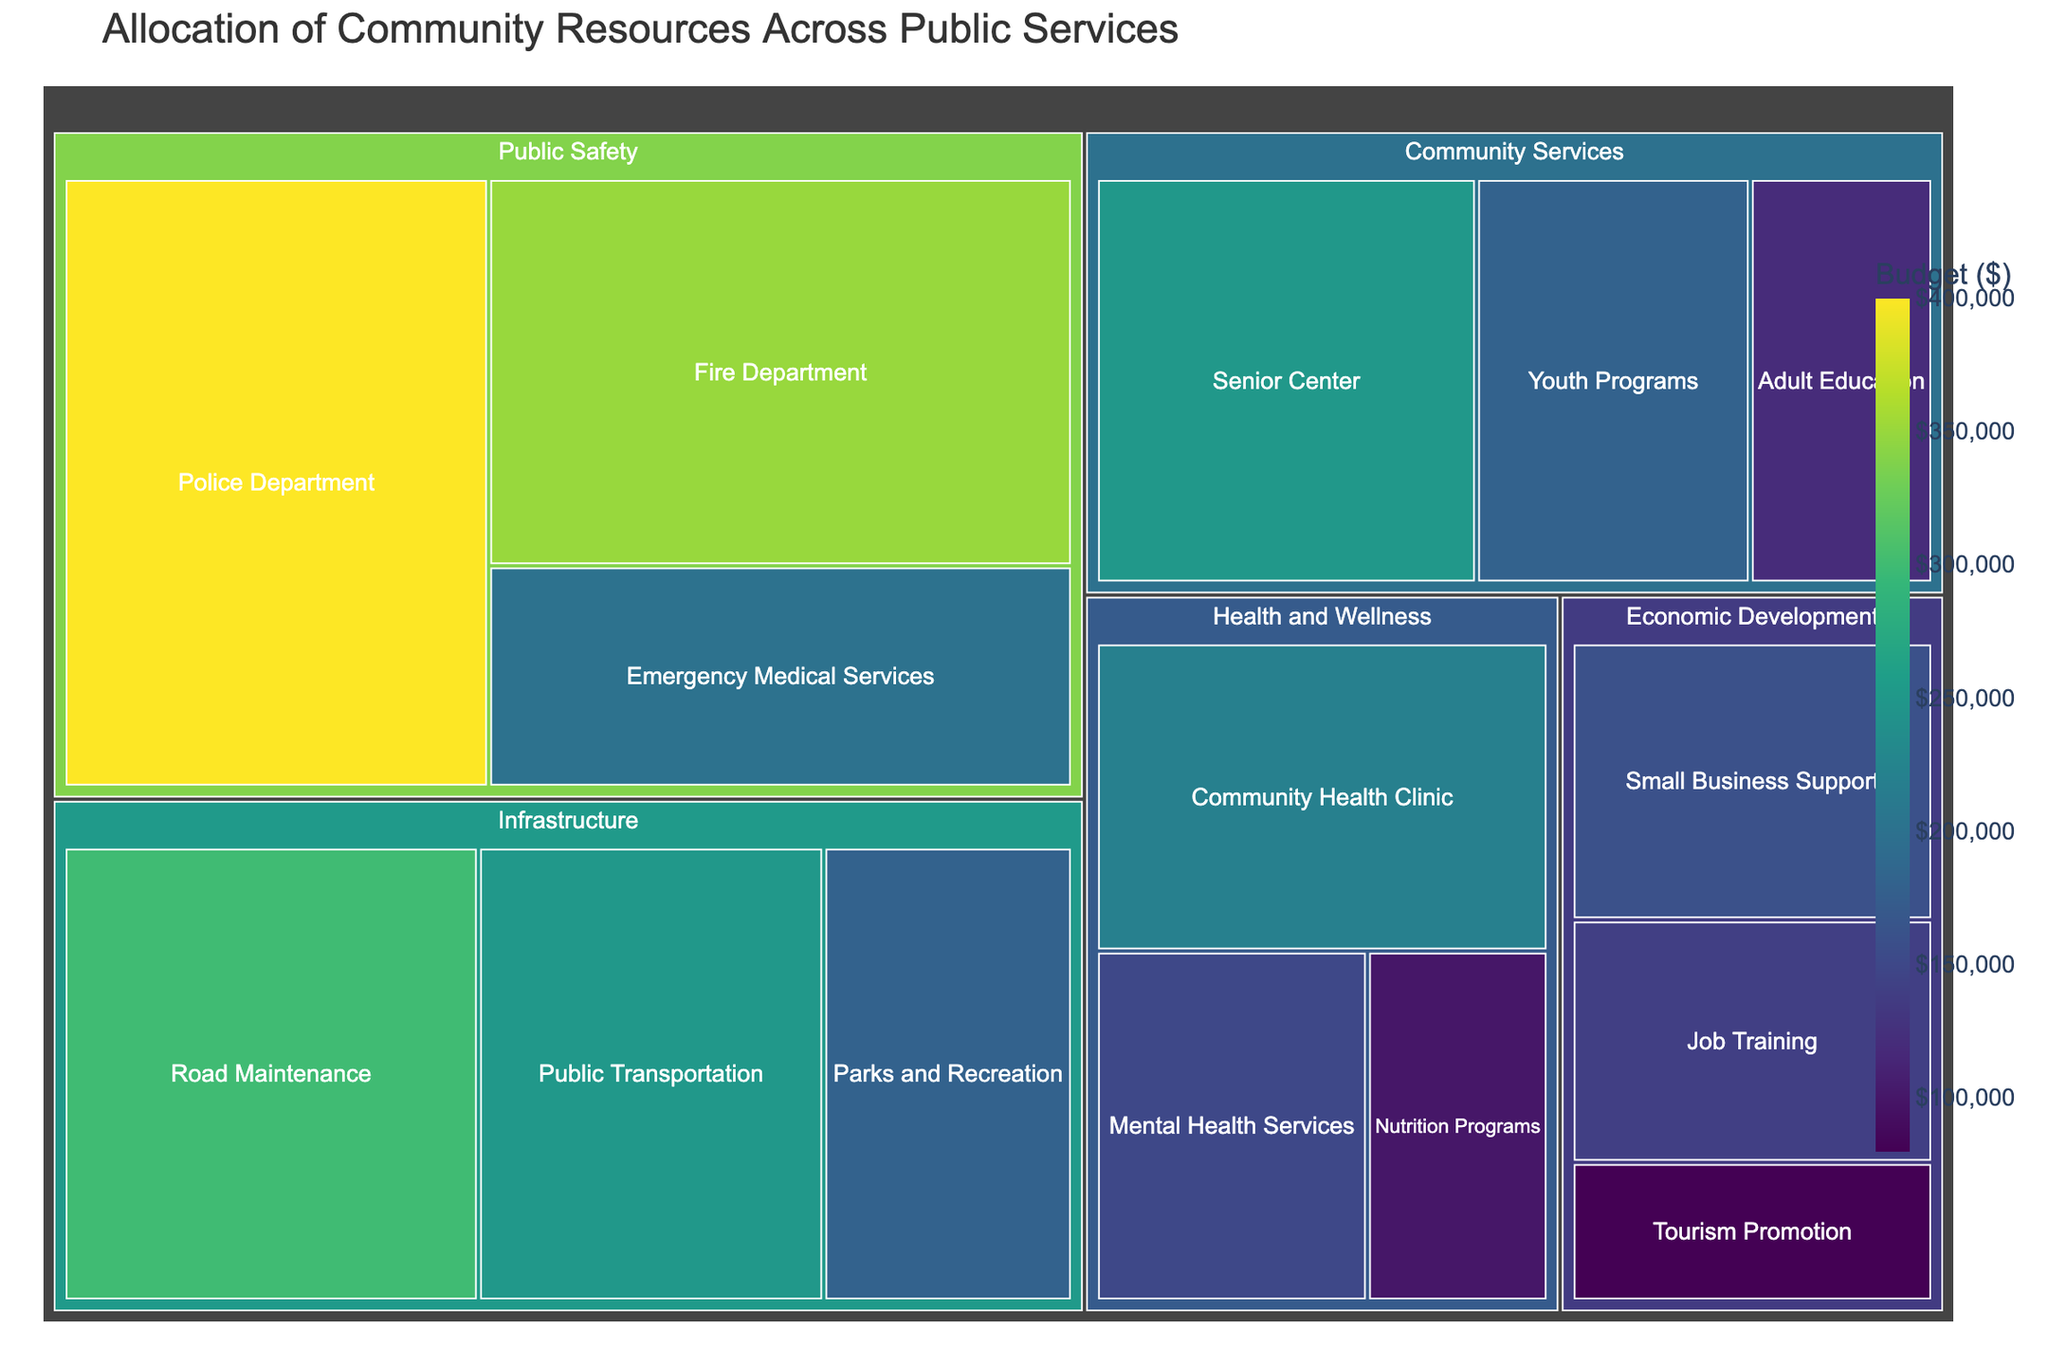What is the title of the figure? The title can be seen at the top of the figure, usually in a larger font to stand out.
Answer: Allocation of Community Resources Across Public Services Which subcategory within Public Safety has the highest budget allocation? Look within the 'Public Safety' category in the treemap and compare the budget values of the subcategories.
Answer: Police Department What is the total budget for Community Services? Identify the budget values for each subcategory within 'Community Services' and sum them up: 250,000 (Senior Center) + 180,000 (Youth Programs) + 120,000 (Adult Education).
Answer: 550,000 Is the allocation for Fire Department greater than or less than Public Transportation? Locate the 'Fire Department' and 'Public Transportation' subcategories on the treemap and compare their budget values. The Fire Department has 350,000 and Public Transportation has 250,000.
Answer: Greater than How does the budget for Economic Development compare to Health and Wellness? Sum the budget values of each subcategory within 'Economic Development' and 'Health and Wellness'. Economic Development: 160,000 (Small Business Support) + 140,000 (Job Training) + 80,000 (Tourism Promotion) = 380,000. Health and Wellness: 220,000 (Community Health Clinic) + 150,000 (Mental Health Services) + 100,000 (Nutrition Programs) = 470,000.
Answer: Health and Wellness has a higher budget Which subcategory in the Health and Wellness category has the least budget allocation? Look within the 'Health and Wellness' category and find the subcategory with the smallest budget value.
Answer: Nutrition Programs How many subcategories are there in the Infrastructure category? Count the number of labeled subcategories within the 'Infrastructure' category on the treemap.
Answer: 3 What is the difference in budget allocation between Road Maintenance and Parks and Recreation? Subtract the budget of Parks and Recreation from Road Maintenance: 300,000 (Road Maintenance) - 180,000 (Parks and Recreation).
Answer: 120,000 Which category has the smallest total allocated budget when considering all its subcategories? Sum the budget values for all subcategories within each category and compare.
Answer: Economic Development 